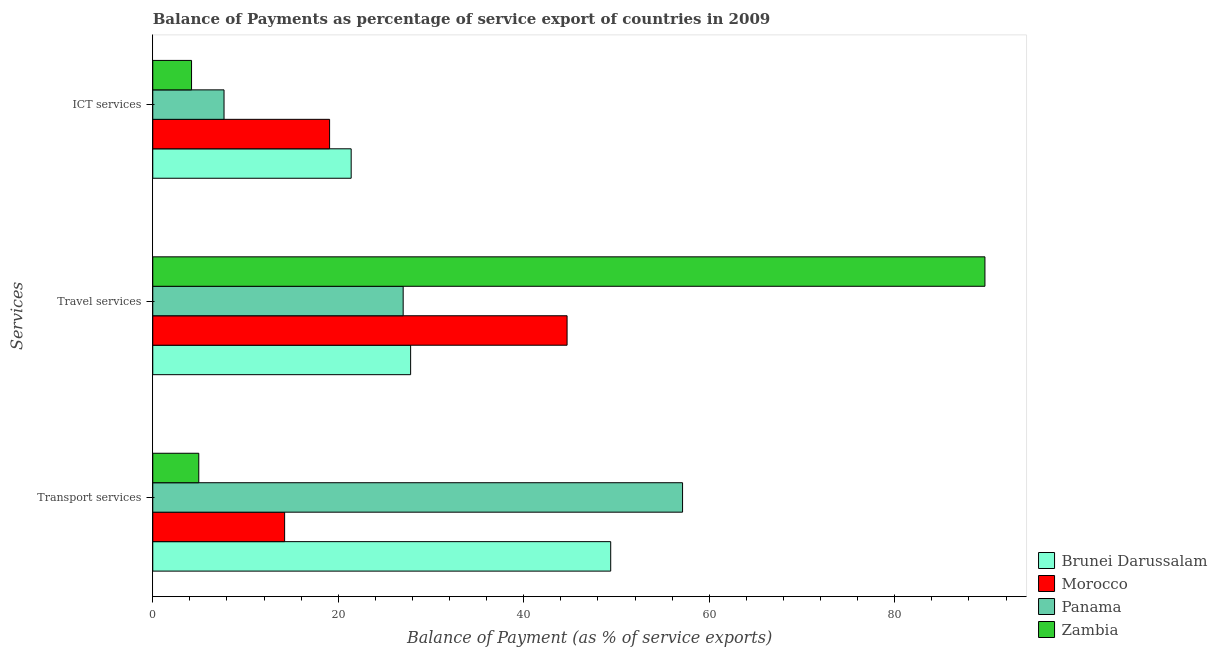How many different coloured bars are there?
Give a very brief answer. 4. Are the number of bars on each tick of the Y-axis equal?
Provide a short and direct response. Yes. What is the label of the 2nd group of bars from the top?
Offer a very short reply. Travel services. What is the balance of payment of travel services in Morocco?
Give a very brief answer. 44.67. Across all countries, what is the maximum balance of payment of travel services?
Give a very brief answer. 89.73. Across all countries, what is the minimum balance of payment of ict services?
Make the answer very short. 4.18. In which country was the balance of payment of travel services maximum?
Ensure brevity in your answer.  Zambia. In which country was the balance of payment of travel services minimum?
Offer a very short reply. Panama. What is the total balance of payment of ict services in the graph?
Provide a short and direct response. 52.32. What is the difference between the balance of payment of ict services in Morocco and that in Panama?
Your answer should be very brief. 11.38. What is the difference between the balance of payment of travel services in Morocco and the balance of payment of transport services in Panama?
Your answer should be very brief. -12.45. What is the average balance of payment of travel services per country?
Provide a short and direct response. 47.3. What is the difference between the balance of payment of ict services and balance of payment of travel services in Brunei Darussalam?
Give a very brief answer. -6.41. In how many countries, is the balance of payment of transport services greater than 88 %?
Give a very brief answer. 0. What is the ratio of the balance of payment of travel services in Morocco to that in Panama?
Your answer should be very brief. 1.65. Is the difference between the balance of payment of travel services in Brunei Darussalam and Zambia greater than the difference between the balance of payment of transport services in Brunei Darussalam and Zambia?
Your answer should be very brief. No. What is the difference between the highest and the second highest balance of payment of travel services?
Make the answer very short. 45.05. What is the difference between the highest and the lowest balance of payment of ict services?
Ensure brevity in your answer.  17.21. In how many countries, is the balance of payment of ict services greater than the average balance of payment of ict services taken over all countries?
Keep it short and to the point. 2. What does the 3rd bar from the top in ICT services represents?
Make the answer very short. Morocco. What does the 1st bar from the bottom in Transport services represents?
Your answer should be very brief. Brunei Darussalam. Is it the case that in every country, the sum of the balance of payment of transport services and balance of payment of travel services is greater than the balance of payment of ict services?
Keep it short and to the point. Yes. How many bars are there?
Your response must be concise. 12. How many countries are there in the graph?
Provide a short and direct response. 4. How many legend labels are there?
Your response must be concise. 4. How are the legend labels stacked?
Make the answer very short. Vertical. What is the title of the graph?
Ensure brevity in your answer.  Balance of Payments as percentage of service export of countries in 2009. What is the label or title of the X-axis?
Make the answer very short. Balance of Payment (as % of service exports). What is the label or title of the Y-axis?
Offer a very short reply. Services. What is the Balance of Payment (as % of service exports) in Brunei Darussalam in Transport services?
Keep it short and to the point. 49.38. What is the Balance of Payment (as % of service exports) in Morocco in Transport services?
Provide a succinct answer. 14.22. What is the Balance of Payment (as % of service exports) of Panama in Transport services?
Your answer should be compact. 57.12. What is the Balance of Payment (as % of service exports) of Zambia in Transport services?
Make the answer very short. 4.96. What is the Balance of Payment (as % of service exports) of Brunei Darussalam in Travel services?
Keep it short and to the point. 27.8. What is the Balance of Payment (as % of service exports) in Morocco in Travel services?
Your response must be concise. 44.67. What is the Balance of Payment (as % of service exports) in Panama in Travel services?
Ensure brevity in your answer.  27. What is the Balance of Payment (as % of service exports) in Zambia in Travel services?
Your answer should be compact. 89.73. What is the Balance of Payment (as % of service exports) of Brunei Darussalam in ICT services?
Your answer should be compact. 21.39. What is the Balance of Payment (as % of service exports) of Morocco in ICT services?
Offer a terse response. 19.06. What is the Balance of Payment (as % of service exports) of Panama in ICT services?
Keep it short and to the point. 7.68. What is the Balance of Payment (as % of service exports) in Zambia in ICT services?
Your response must be concise. 4.18. Across all Services, what is the maximum Balance of Payment (as % of service exports) in Brunei Darussalam?
Provide a succinct answer. 49.38. Across all Services, what is the maximum Balance of Payment (as % of service exports) of Morocco?
Offer a very short reply. 44.67. Across all Services, what is the maximum Balance of Payment (as % of service exports) of Panama?
Ensure brevity in your answer.  57.12. Across all Services, what is the maximum Balance of Payment (as % of service exports) in Zambia?
Make the answer very short. 89.73. Across all Services, what is the minimum Balance of Payment (as % of service exports) of Brunei Darussalam?
Your answer should be very brief. 21.39. Across all Services, what is the minimum Balance of Payment (as % of service exports) in Morocco?
Provide a short and direct response. 14.22. Across all Services, what is the minimum Balance of Payment (as % of service exports) of Panama?
Your answer should be compact. 7.68. Across all Services, what is the minimum Balance of Payment (as % of service exports) in Zambia?
Keep it short and to the point. 4.18. What is the total Balance of Payment (as % of service exports) of Brunei Darussalam in the graph?
Your answer should be compact. 98.57. What is the total Balance of Payment (as % of service exports) in Morocco in the graph?
Ensure brevity in your answer.  77.95. What is the total Balance of Payment (as % of service exports) of Panama in the graph?
Ensure brevity in your answer.  91.81. What is the total Balance of Payment (as % of service exports) in Zambia in the graph?
Keep it short and to the point. 98.87. What is the difference between the Balance of Payment (as % of service exports) of Brunei Darussalam in Transport services and that in Travel services?
Provide a short and direct response. 21.57. What is the difference between the Balance of Payment (as % of service exports) in Morocco in Transport services and that in Travel services?
Keep it short and to the point. -30.46. What is the difference between the Balance of Payment (as % of service exports) in Panama in Transport services and that in Travel services?
Give a very brief answer. 30.13. What is the difference between the Balance of Payment (as % of service exports) of Zambia in Transport services and that in Travel services?
Provide a succinct answer. -84.77. What is the difference between the Balance of Payment (as % of service exports) in Brunei Darussalam in Transport services and that in ICT services?
Your answer should be very brief. 27.98. What is the difference between the Balance of Payment (as % of service exports) in Morocco in Transport services and that in ICT services?
Make the answer very short. -4.85. What is the difference between the Balance of Payment (as % of service exports) in Panama in Transport services and that in ICT services?
Your response must be concise. 49.44. What is the difference between the Balance of Payment (as % of service exports) of Zambia in Transport services and that in ICT services?
Your response must be concise. 0.78. What is the difference between the Balance of Payment (as % of service exports) of Brunei Darussalam in Travel services and that in ICT services?
Offer a very short reply. 6.41. What is the difference between the Balance of Payment (as % of service exports) in Morocco in Travel services and that in ICT services?
Keep it short and to the point. 25.61. What is the difference between the Balance of Payment (as % of service exports) in Panama in Travel services and that in ICT services?
Give a very brief answer. 19.31. What is the difference between the Balance of Payment (as % of service exports) of Zambia in Travel services and that in ICT services?
Your answer should be very brief. 85.55. What is the difference between the Balance of Payment (as % of service exports) of Brunei Darussalam in Transport services and the Balance of Payment (as % of service exports) of Morocco in Travel services?
Your response must be concise. 4.7. What is the difference between the Balance of Payment (as % of service exports) of Brunei Darussalam in Transport services and the Balance of Payment (as % of service exports) of Panama in Travel services?
Give a very brief answer. 22.38. What is the difference between the Balance of Payment (as % of service exports) in Brunei Darussalam in Transport services and the Balance of Payment (as % of service exports) in Zambia in Travel services?
Offer a terse response. -40.35. What is the difference between the Balance of Payment (as % of service exports) of Morocco in Transport services and the Balance of Payment (as % of service exports) of Panama in Travel services?
Keep it short and to the point. -12.78. What is the difference between the Balance of Payment (as % of service exports) in Morocco in Transport services and the Balance of Payment (as % of service exports) in Zambia in Travel services?
Make the answer very short. -75.51. What is the difference between the Balance of Payment (as % of service exports) in Panama in Transport services and the Balance of Payment (as % of service exports) in Zambia in Travel services?
Keep it short and to the point. -32.6. What is the difference between the Balance of Payment (as % of service exports) of Brunei Darussalam in Transport services and the Balance of Payment (as % of service exports) of Morocco in ICT services?
Ensure brevity in your answer.  30.31. What is the difference between the Balance of Payment (as % of service exports) in Brunei Darussalam in Transport services and the Balance of Payment (as % of service exports) in Panama in ICT services?
Your response must be concise. 41.69. What is the difference between the Balance of Payment (as % of service exports) of Brunei Darussalam in Transport services and the Balance of Payment (as % of service exports) of Zambia in ICT services?
Make the answer very short. 45.2. What is the difference between the Balance of Payment (as % of service exports) of Morocco in Transport services and the Balance of Payment (as % of service exports) of Panama in ICT services?
Keep it short and to the point. 6.53. What is the difference between the Balance of Payment (as % of service exports) of Morocco in Transport services and the Balance of Payment (as % of service exports) of Zambia in ICT services?
Your answer should be very brief. 10.04. What is the difference between the Balance of Payment (as % of service exports) of Panama in Transport services and the Balance of Payment (as % of service exports) of Zambia in ICT services?
Your response must be concise. 52.94. What is the difference between the Balance of Payment (as % of service exports) in Brunei Darussalam in Travel services and the Balance of Payment (as % of service exports) in Morocco in ICT services?
Ensure brevity in your answer.  8.74. What is the difference between the Balance of Payment (as % of service exports) in Brunei Darussalam in Travel services and the Balance of Payment (as % of service exports) in Panama in ICT services?
Ensure brevity in your answer.  20.12. What is the difference between the Balance of Payment (as % of service exports) of Brunei Darussalam in Travel services and the Balance of Payment (as % of service exports) of Zambia in ICT services?
Offer a very short reply. 23.62. What is the difference between the Balance of Payment (as % of service exports) in Morocco in Travel services and the Balance of Payment (as % of service exports) in Panama in ICT services?
Provide a succinct answer. 36.99. What is the difference between the Balance of Payment (as % of service exports) in Morocco in Travel services and the Balance of Payment (as % of service exports) in Zambia in ICT services?
Give a very brief answer. 40.49. What is the difference between the Balance of Payment (as % of service exports) of Panama in Travel services and the Balance of Payment (as % of service exports) of Zambia in ICT services?
Your answer should be very brief. 22.82. What is the average Balance of Payment (as % of service exports) of Brunei Darussalam per Services?
Your answer should be very brief. 32.86. What is the average Balance of Payment (as % of service exports) of Morocco per Services?
Your answer should be very brief. 25.98. What is the average Balance of Payment (as % of service exports) in Panama per Services?
Your answer should be very brief. 30.6. What is the average Balance of Payment (as % of service exports) of Zambia per Services?
Keep it short and to the point. 32.96. What is the difference between the Balance of Payment (as % of service exports) of Brunei Darussalam and Balance of Payment (as % of service exports) of Morocco in Transport services?
Offer a very short reply. 35.16. What is the difference between the Balance of Payment (as % of service exports) in Brunei Darussalam and Balance of Payment (as % of service exports) in Panama in Transport services?
Offer a terse response. -7.75. What is the difference between the Balance of Payment (as % of service exports) of Brunei Darussalam and Balance of Payment (as % of service exports) of Zambia in Transport services?
Offer a terse response. 44.42. What is the difference between the Balance of Payment (as % of service exports) in Morocco and Balance of Payment (as % of service exports) in Panama in Transport services?
Offer a terse response. -42.91. What is the difference between the Balance of Payment (as % of service exports) of Morocco and Balance of Payment (as % of service exports) of Zambia in Transport services?
Your answer should be very brief. 9.26. What is the difference between the Balance of Payment (as % of service exports) of Panama and Balance of Payment (as % of service exports) of Zambia in Transport services?
Offer a terse response. 52.16. What is the difference between the Balance of Payment (as % of service exports) of Brunei Darussalam and Balance of Payment (as % of service exports) of Morocco in Travel services?
Give a very brief answer. -16.87. What is the difference between the Balance of Payment (as % of service exports) of Brunei Darussalam and Balance of Payment (as % of service exports) of Panama in Travel services?
Keep it short and to the point. 0.8. What is the difference between the Balance of Payment (as % of service exports) of Brunei Darussalam and Balance of Payment (as % of service exports) of Zambia in Travel services?
Your response must be concise. -61.92. What is the difference between the Balance of Payment (as % of service exports) in Morocco and Balance of Payment (as % of service exports) in Panama in Travel services?
Offer a very short reply. 17.67. What is the difference between the Balance of Payment (as % of service exports) in Morocco and Balance of Payment (as % of service exports) in Zambia in Travel services?
Your answer should be compact. -45.05. What is the difference between the Balance of Payment (as % of service exports) of Panama and Balance of Payment (as % of service exports) of Zambia in Travel services?
Give a very brief answer. -62.73. What is the difference between the Balance of Payment (as % of service exports) of Brunei Darussalam and Balance of Payment (as % of service exports) of Morocco in ICT services?
Offer a terse response. 2.33. What is the difference between the Balance of Payment (as % of service exports) of Brunei Darussalam and Balance of Payment (as % of service exports) of Panama in ICT services?
Ensure brevity in your answer.  13.71. What is the difference between the Balance of Payment (as % of service exports) in Brunei Darussalam and Balance of Payment (as % of service exports) in Zambia in ICT services?
Your answer should be very brief. 17.21. What is the difference between the Balance of Payment (as % of service exports) in Morocco and Balance of Payment (as % of service exports) in Panama in ICT services?
Keep it short and to the point. 11.38. What is the difference between the Balance of Payment (as % of service exports) in Morocco and Balance of Payment (as % of service exports) in Zambia in ICT services?
Your answer should be very brief. 14.88. What is the difference between the Balance of Payment (as % of service exports) in Panama and Balance of Payment (as % of service exports) in Zambia in ICT services?
Offer a terse response. 3.5. What is the ratio of the Balance of Payment (as % of service exports) in Brunei Darussalam in Transport services to that in Travel services?
Offer a terse response. 1.78. What is the ratio of the Balance of Payment (as % of service exports) of Morocco in Transport services to that in Travel services?
Give a very brief answer. 0.32. What is the ratio of the Balance of Payment (as % of service exports) of Panama in Transport services to that in Travel services?
Offer a very short reply. 2.12. What is the ratio of the Balance of Payment (as % of service exports) of Zambia in Transport services to that in Travel services?
Your answer should be compact. 0.06. What is the ratio of the Balance of Payment (as % of service exports) of Brunei Darussalam in Transport services to that in ICT services?
Make the answer very short. 2.31. What is the ratio of the Balance of Payment (as % of service exports) of Morocco in Transport services to that in ICT services?
Keep it short and to the point. 0.75. What is the ratio of the Balance of Payment (as % of service exports) in Panama in Transport services to that in ICT services?
Offer a terse response. 7.43. What is the ratio of the Balance of Payment (as % of service exports) in Zambia in Transport services to that in ICT services?
Provide a succinct answer. 1.19. What is the ratio of the Balance of Payment (as % of service exports) of Brunei Darussalam in Travel services to that in ICT services?
Your answer should be compact. 1.3. What is the ratio of the Balance of Payment (as % of service exports) of Morocco in Travel services to that in ICT services?
Your response must be concise. 2.34. What is the ratio of the Balance of Payment (as % of service exports) of Panama in Travel services to that in ICT services?
Ensure brevity in your answer.  3.51. What is the ratio of the Balance of Payment (as % of service exports) of Zambia in Travel services to that in ICT services?
Give a very brief answer. 21.46. What is the difference between the highest and the second highest Balance of Payment (as % of service exports) of Brunei Darussalam?
Make the answer very short. 21.57. What is the difference between the highest and the second highest Balance of Payment (as % of service exports) in Morocco?
Provide a succinct answer. 25.61. What is the difference between the highest and the second highest Balance of Payment (as % of service exports) of Panama?
Give a very brief answer. 30.13. What is the difference between the highest and the second highest Balance of Payment (as % of service exports) of Zambia?
Your response must be concise. 84.77. What is the difference between the highest and the lowest Balance of Payment (as % of service exports) of Brunei Darussalam?
Make the answer very short. 27.98. What is the difference between the highest and the lowest Balance of Payment (as % of service exports) in Morocco?
Give a very brief answer. 30.46. What is the difference between the highest and the lowest Balance of Payment (as % of service exports) of Panama?
Keep it short and to the point. 49.44. What is the difference between the highest and the lowest Balance of Payment (as % of service exports) of Zambia?
Your response must be concise. 85.55. 